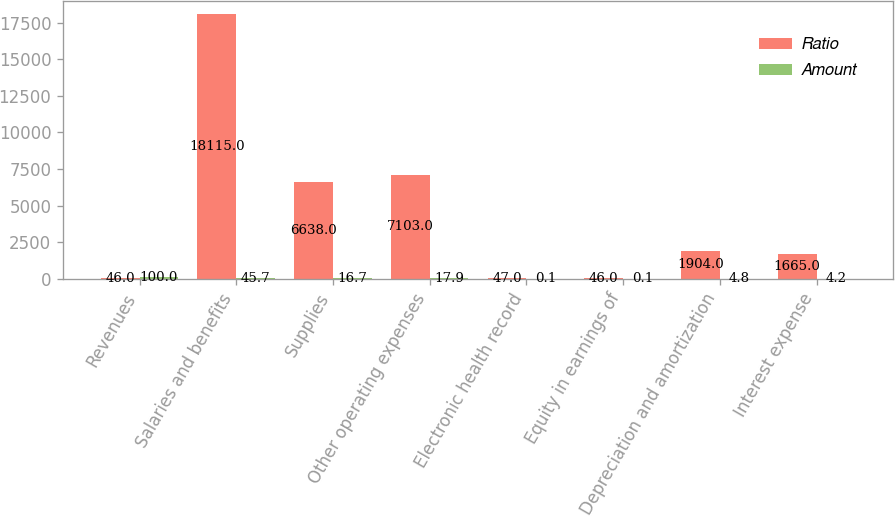Convert chart to OTSL. <chart><loc_0><loc_0><loc_500><loc_500><stacked_bar_chart><ecel><fcel>Revenues<fcel>Salaries and benefits<fcel>Supplies<fcel>Other operating expenses<fcel>Electronic health record<fcel>Equity in earnings of<fcel>Depreciation and amortization<fcel>Interest expense<nl><fcel>Ratio<fcel>46<fcel>18115<fcel>6638<fcel>7103<fcel>47<fcel>46<fcel>1904<fcel>1665<nl><fcel>Amount<fcel>100<fcel>45.7<fcel>16.7<fcel>17.9<fcel>0.1<fcel>0.1<fcel>4.8<fcel>4.2<nl></chart> 